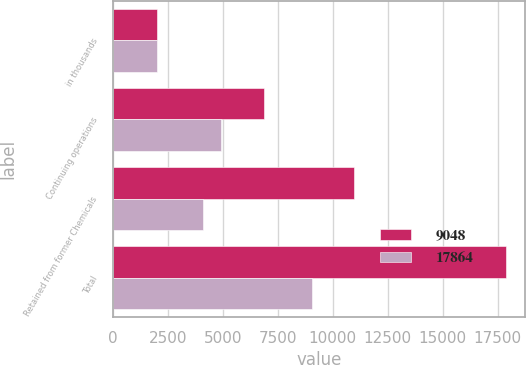<chart> <loc_0><loc_0><loc_500><loc_500><stacked_bar_chart><ecel><fcel>in thousands<fcel>Continuing operations<fcel>Retained from former Chemicals<fcel>Total<nl><fcel>9048<fcel>2015<fcel>6876<fcel>10988<fcel>17864<nl><fcel>17864<fcel>2014<fcel>4919<fcel>4129<fcel>9048<nl></chart> 